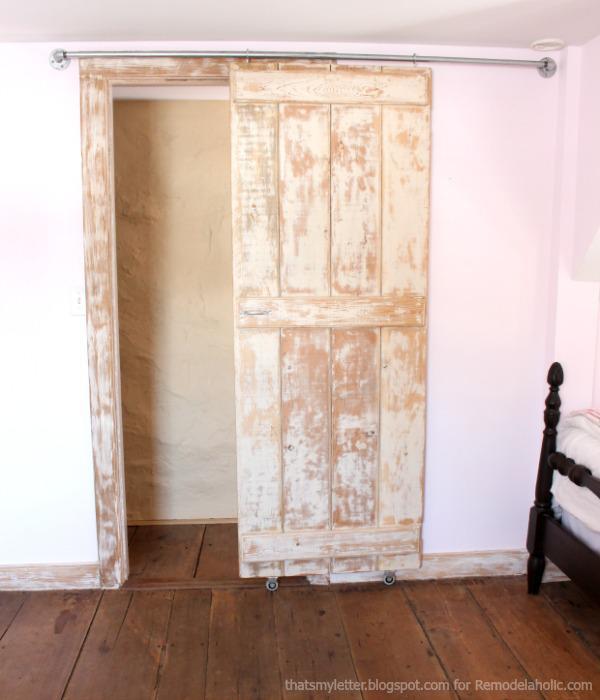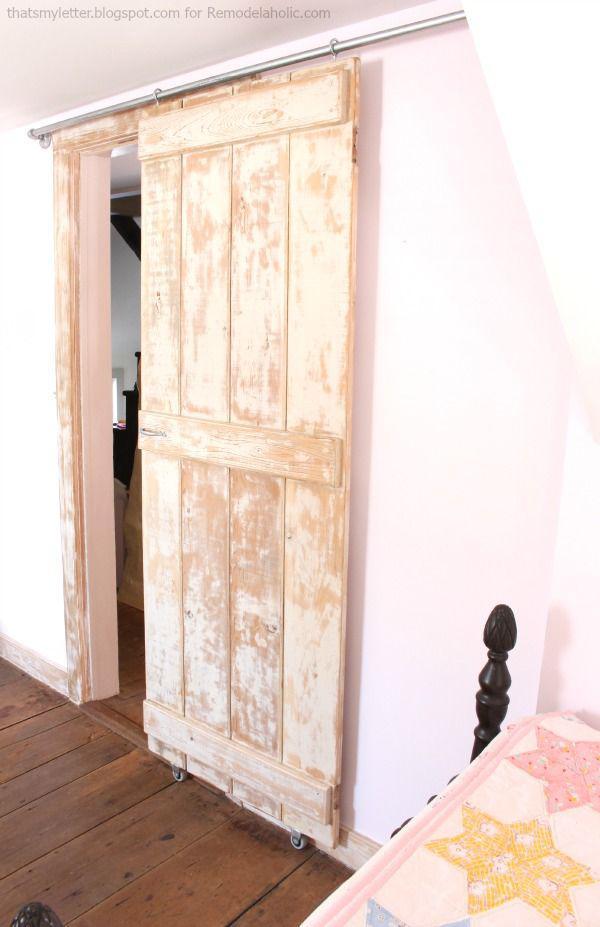The first image is the image on the left, the second image is the image on the right. Assess this claim about the two images: "There is a lamp in one of the images.". Correct or not? Answer yes or no. No. 